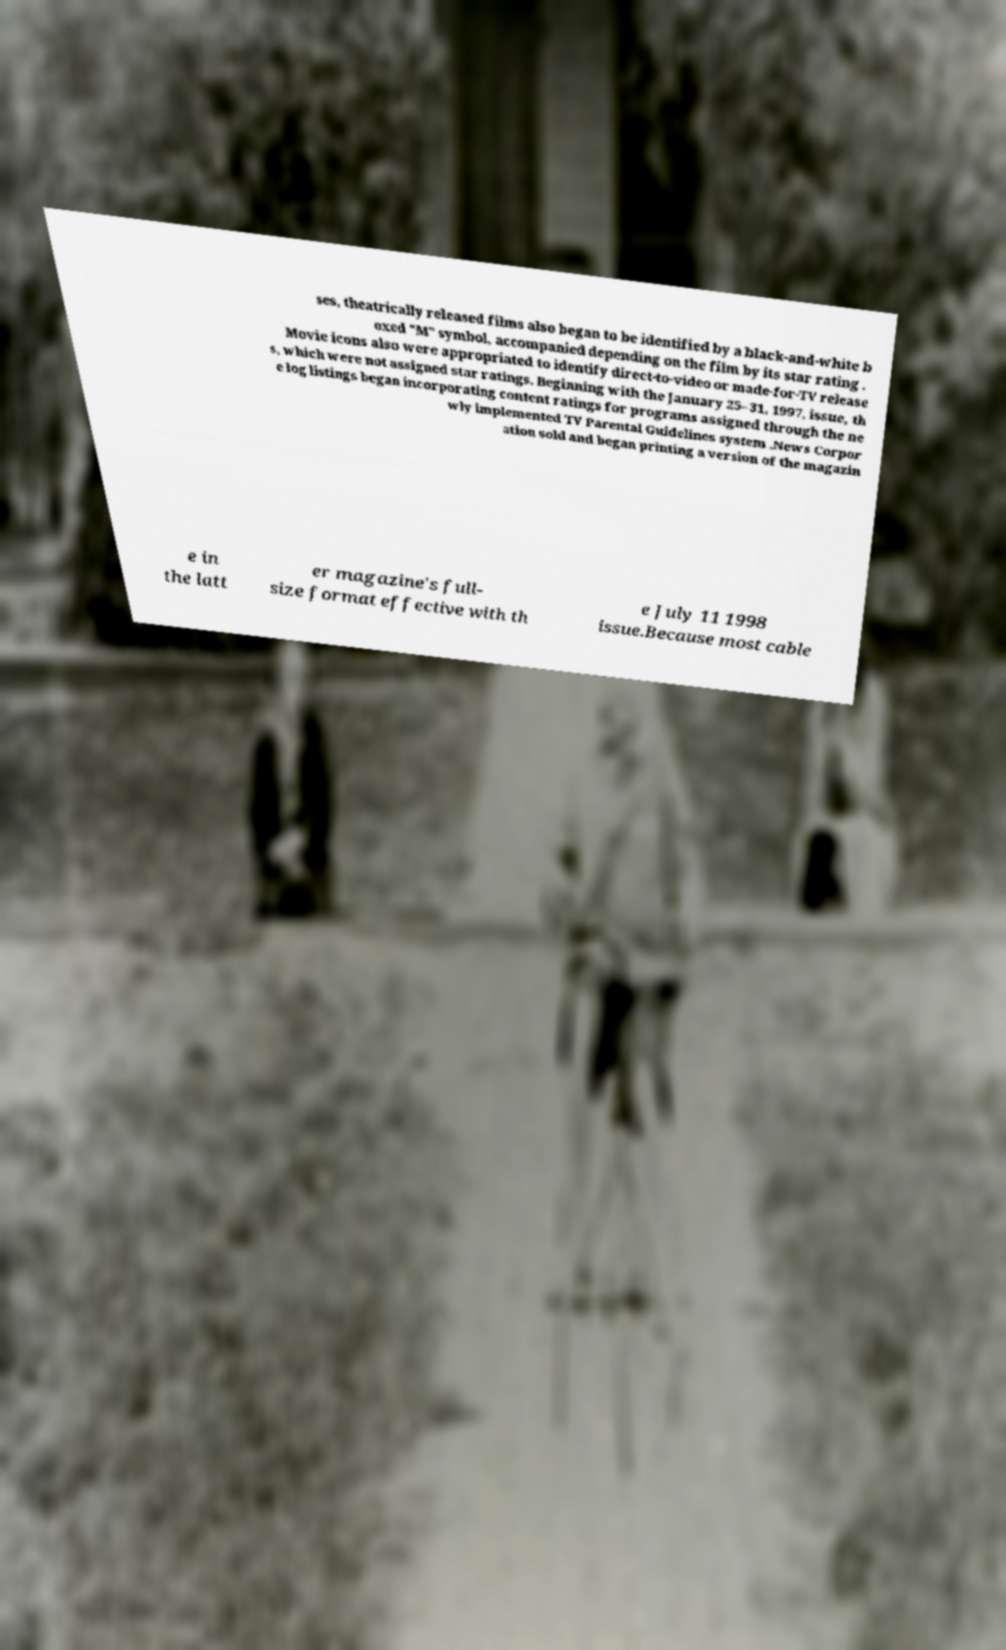There's text embedded in this image that I need extracted. Can you transcribe it verbatim? ses, theatrically released films also began to be identified by a black-and-white b oxed "M" symbol, accompanied depending on the film by its star rating . Movie icons also were appropriated to identify direct-to-video or made-for-TV release s, which were not assigned star ratings. Beginning with the January 25–31, 1997, issue, th e log listings began incorporating content ratings for programs assigned through the ne wly implemented TV Parental Guidelines system .News Corpor ation sold and began printing a version of the magazin e in the latt er magazine's full- size format effective with th e July 11 1998 issue.Because most cable 